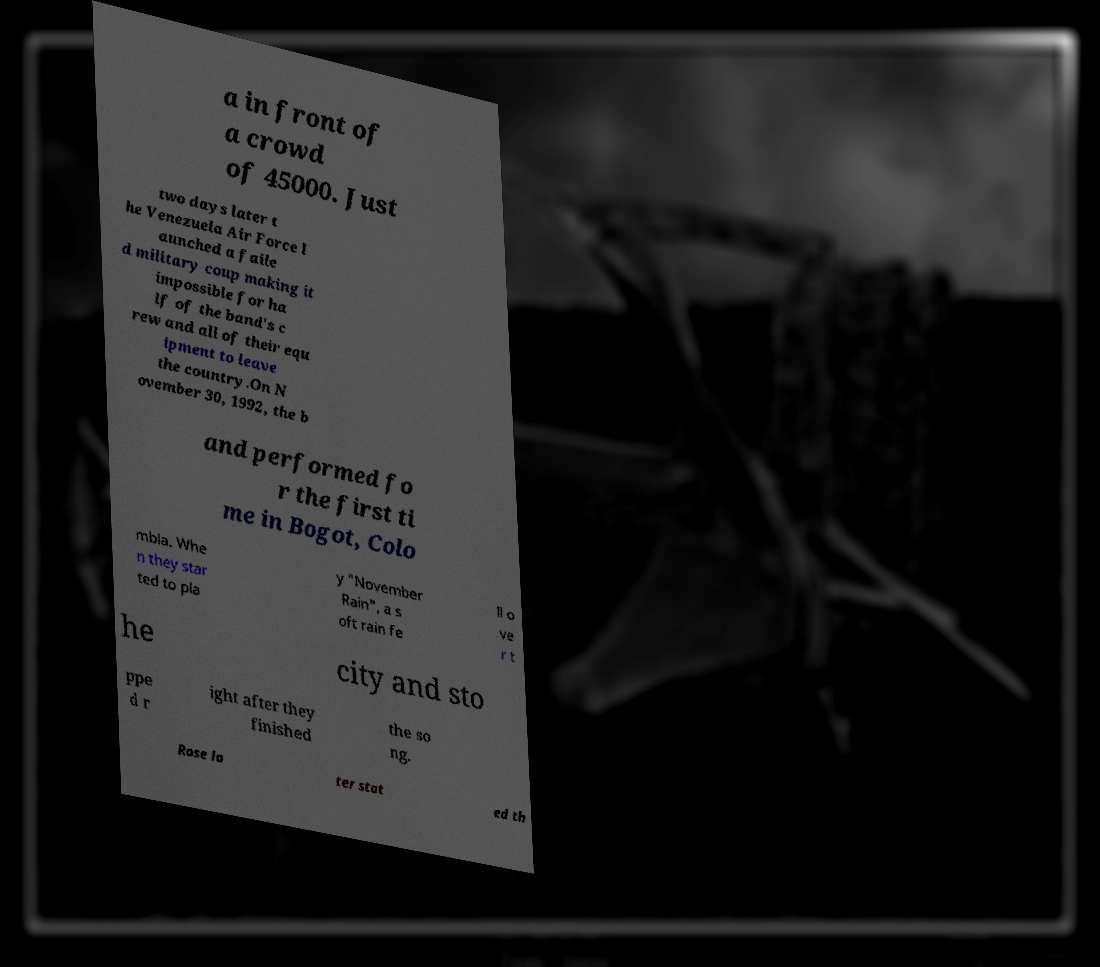Please identify and transcribe the text found in this image. a in front of a crowd of 45000. Just two days later t he Venezuela Air Force l aunched a faile d military coup making it impossible for ha lf of the band's c rew and all of their equ ipment to leave the country.On N ovember 30, 1992, the b and performed fo r the first ti me in Bogot, Colo mbia. Whe n they star ted to pla y "November Rain", a s oft rain fe ll o ve r t he city and sto ppe d r ight after they finished the so ng. Rose la ter stat ed th 